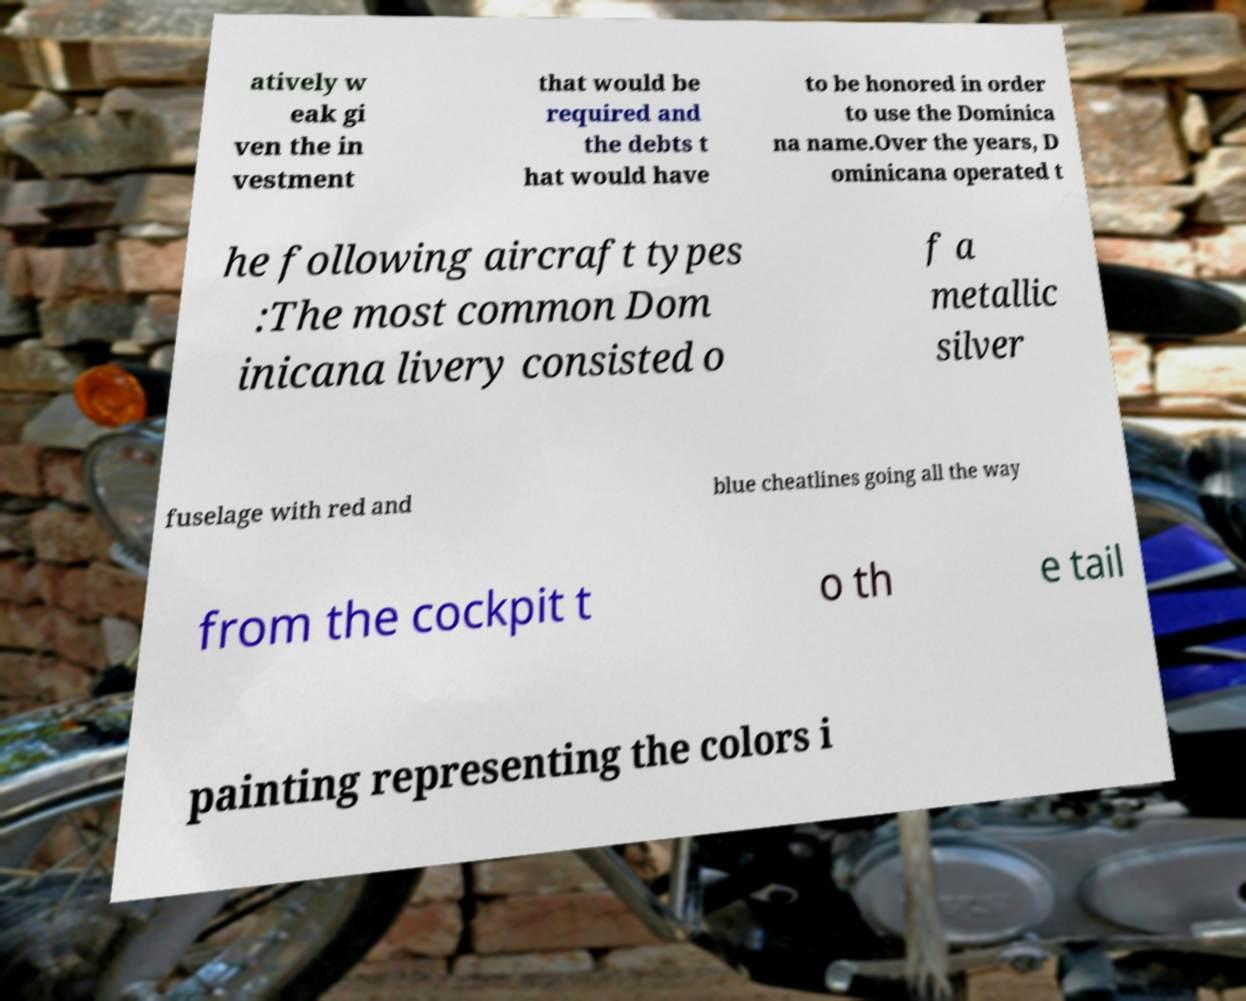Please identify and transcribe the text found in this image. atively w eak gi ven the in vestment that would be required and the debts t hat would have to be honored in order to use the Dominica na name.Over the years, D ominicana operated t he following aircraft types :The most common Dom inicana livery consisted o f a metallic silver fuselage with red and blue cheatlines going all the way from the cockpit t o th e tail painting representing the colors i 